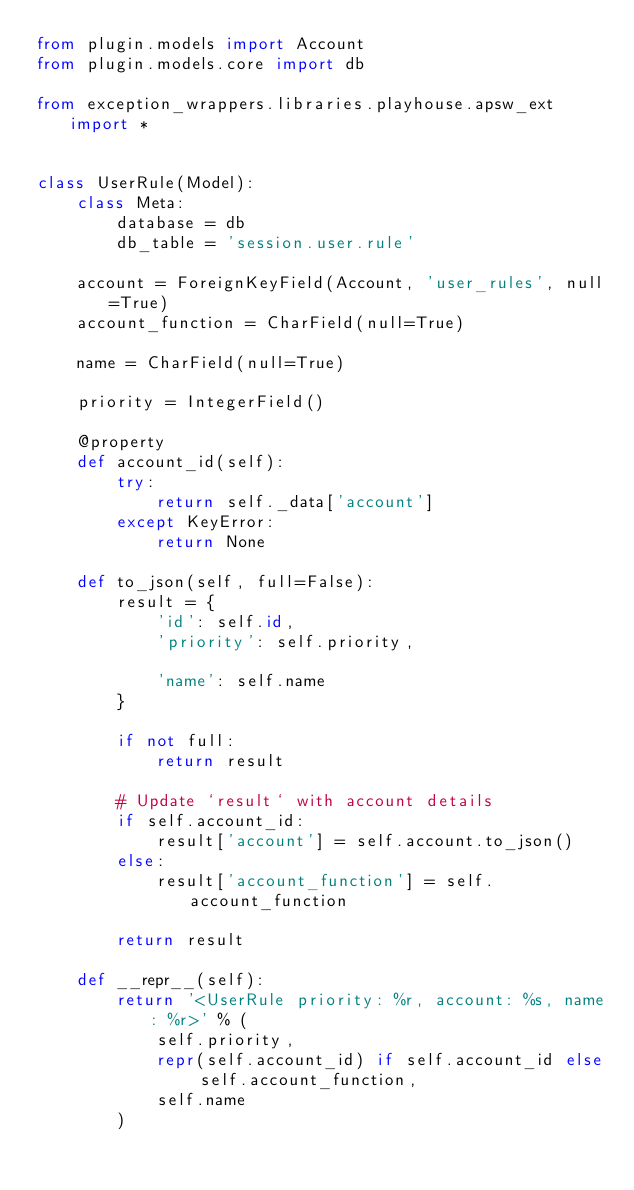<code> <loc_0><loc_0><loc_500><loc_500><_Python_>from plugin.models import Account
from plugin.models.core import db

from exception_wrappers.libraries.playhouse.apsw_ext import *


class UserRule(Model):
    class Meta:
        database = db
        db_table = 'session.user.rule'

    account = ForeignKeyField(Account, 'user_rules', null=True)
    account_function = CharField(null=True)

    name = CharField(null=True)

    priority = IntegerField()

    @property
    def account_id(self):
        try:
            return self._data['account']
        except KeyError:
            return None

    def to_json(self, full=False):
        result = {
            'id': self.id,
            'priority': self.priority,

            'name': self.name
        }

        if not full:
            return result

        # Update `result` with account details
        if self.account_id:
            result['account'] = self.account.to_json()
        else:
            result['account_function'] = self.account_function

        return result

    def __repr__(self):
        return '<UserRule priority: %r, account: %s, name: %r>' % (
            self.priority,
            repr(self.account_id) if self.account_id else self.account_function,
            self.name
        )
</code> 